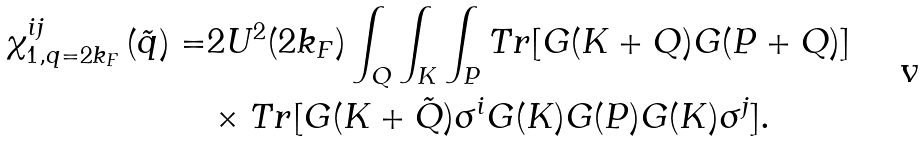<formula> <loc_0><loc_0><loc_500><loc_500>\chi _ { 1 , q = 2 k _ { F } } ^ { i j } \left ( \tilde { q } \right ) = & 2 U ^ { 2 } ( 2 k _ { F } ) \int _ { Q } \int _ { K } \int _ { P } T r [ G ( K + Q ) G ( P + Q ) ] \\ & \times T r [ G ( K + \tilde { Q } ) \sigma ^ { i } G ( K ) G ( P ) G ( K ) \sigma ^ { j } ] .</formula> 